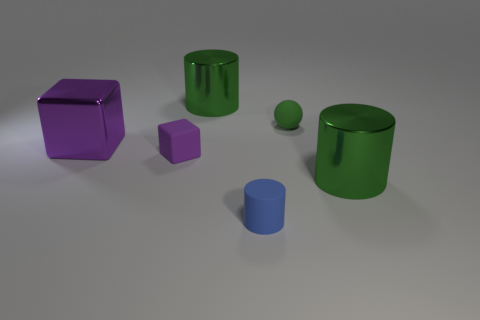There is a blue matte thing that is in front of the green shiny cylinder that is behind the shiny block; what is its size?
Ensure brevity in your answer.  Small. Does the object left of the tiny purple rubber block have the same material as the tiny thing to the left of the small rubber cylinder?
Offer a very short reply. No. Is the color of the metallic thing that is to the right of the matte cylinder the same as the matte cube?
Make the answer very short. No. There is a small green matte sphere; what number of purple rubber cubes are in front of it?
Offer a very short reply. 1. Does the large purple thing have the same material as the large cylinder to the left of the green sphere?
Provide a succinct answer. Yes. There is a cylinder that is made of the same material as the small green ball; what is its size?
Give a very brief answer. Small. Are there more metallic blocks that are to the right of the green ball than small blue matte cylinders behind the big purple cube?
Your response must be concise. No. Is there a tiny cyan thing that has the same shape as the tiny green matte thing?
Offer a terse response. No. Do the green thing left of the blue rubber thing and the purple matte cube have the same size?
Your answer should be very brief. No. Are there any red matte balls?
Ensure brevity in your answer.  No. 